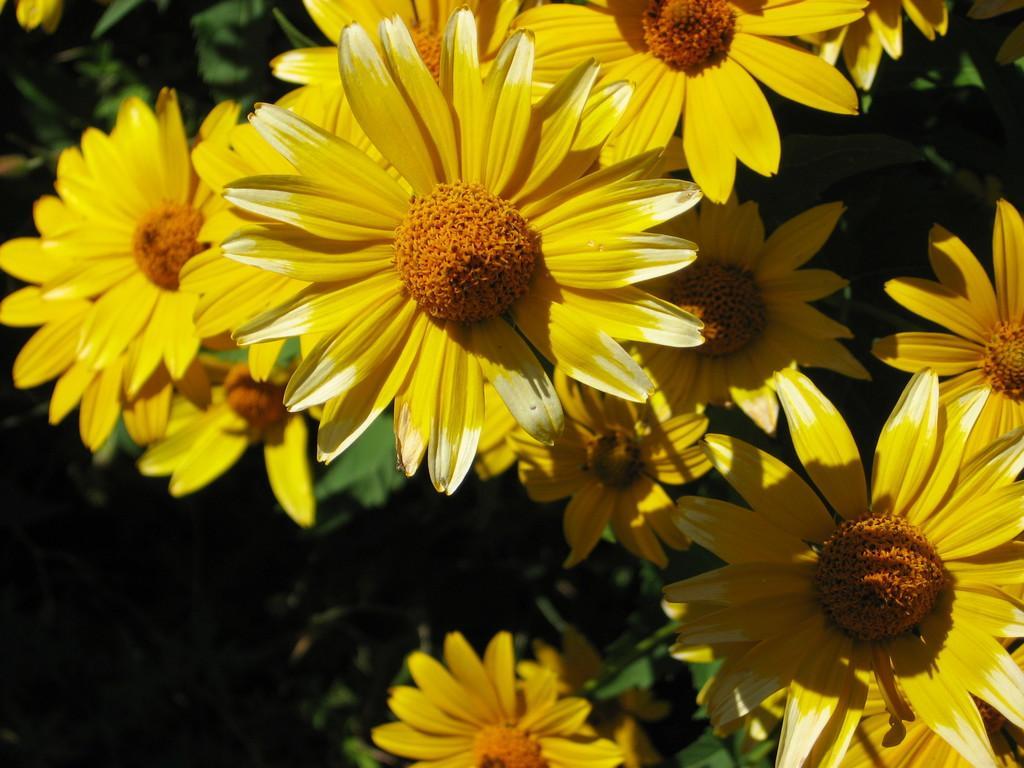Describe this image in one or two sentences. In this picture I can see there are few flowers and it has yellow petals and they are attached to the plants, there are also few leaves and the backdrop is dark. 